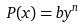<formula> <loc_0><loc_0><loc_500><loc_500>P ( x ) = b y ^ { n }</formula> 